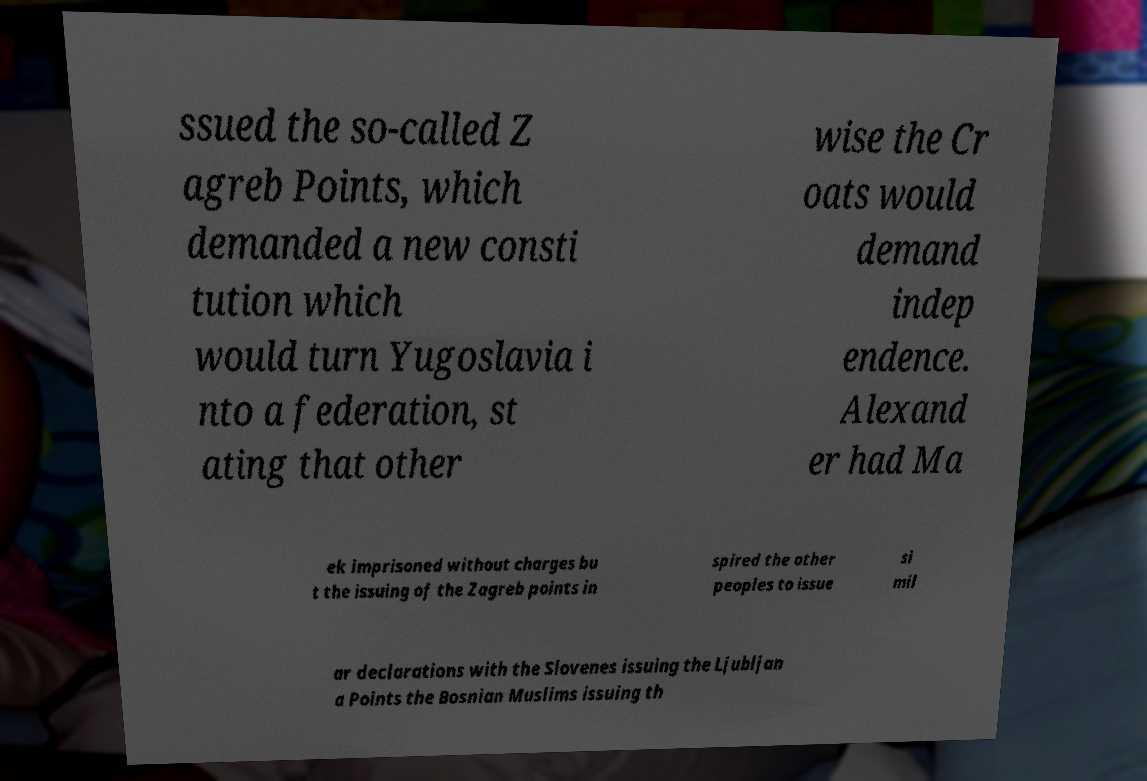For documentation purposes, I need the text within this image transcribed. Could you provide that? ssued the so-called Z agreb Points, which demanded a new consti tution which would turn Yugoslavia i nto a federation, st ating that other wise the Cr oats would demand indep endence. Alexand er had Ma ek imprisoned without charges bu t the issuing of the Zagreb points in spired the other peoples to issue si mil ar declarations with the Slovenes issuing the Ljubljan a Points the Bosnian Muslims issuing th 